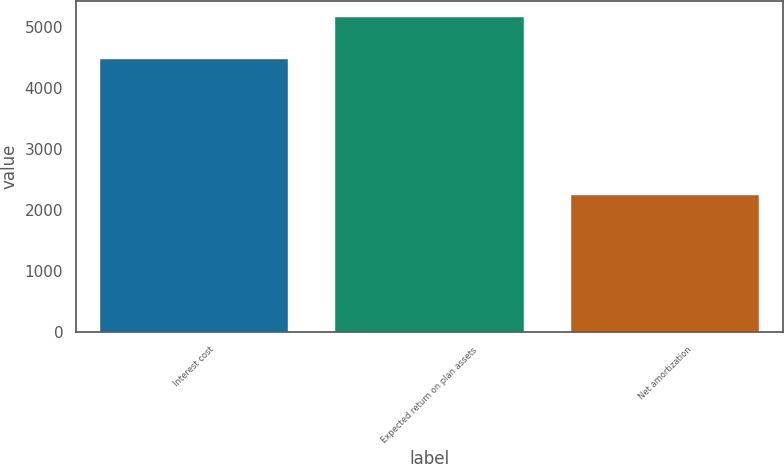Convert chart. <chart><loc_0><loc_0><loc_500><loc_500><bar_chart><fcel>Interest cost<fcel>Expected return on plan assets<fcel>Net amortization<nl><fcel>4484<fcel>5169<fcel>2244<nl></chart> 